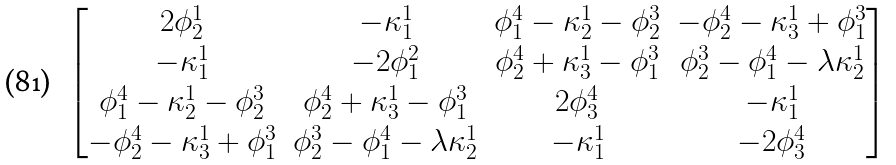Convert formula to latex. <formula><loc_0><loc_0><loc_500><loc_500>\begin{bmatrix} 2 \phi _ { 2 } ^ { 1 } & - \kappa _ { 1 } ^ { 1 } & \phi _ { 1 } ^ { 4 } - \kappa _ { 2 } ^ { 1 } - \phi _ { 2 } ^ { 3 } & - \phi _ { 2 } ^ { 4 } - \kappa _ { 3 } ^ { 1 } + \phi _ { 1 } ^ { 3 } \\ - \kappa _ { 1 } ^ { 1 } & - 2 \phi _ { 1 } ^ { 2 } & \phi _ { 2 } ^ { 4 } + \kappa _ { 3 } ^ { 1 } - \phi _ { 1 } ^ { 3 } & \phi _ { 2 } ^ { 3 } - \phi _ { 1 } ^ { 4 } - \lambda \kappa _ { 2 } ^ { 1 } \\ \phi _ { 1 } ^ { 4 } - \kappa _ { 2 } ^ { 1 } - \phi _ { 2 } ^ { 3 } & \phi _ { 2 } ^ { 4 } + \kappa _ { 3 } ^ { 1 } - \phi _ { 1 } ^ { 3 } & 2 \phi _ { 3 } ^ { 4 } & - \kappa _ { 1 } ^ { 1 } \\ - \phi _ { 2 } ^ { 4 } - \kappa _ { 3 } ^ { 1 } + \phi _ { 1 } ^ { 3 } & \phi _ { 2 } ^ { 3 } - \phi _ { 1 } ^ { 4 } - \lambda \kappa _ { 2 } ^ { 1 } & - \kappa _ { 1 } ^ { 1 } & - 2 \phi _ { 3 } ^ { 4 } \end{bmatrix}</formula> 